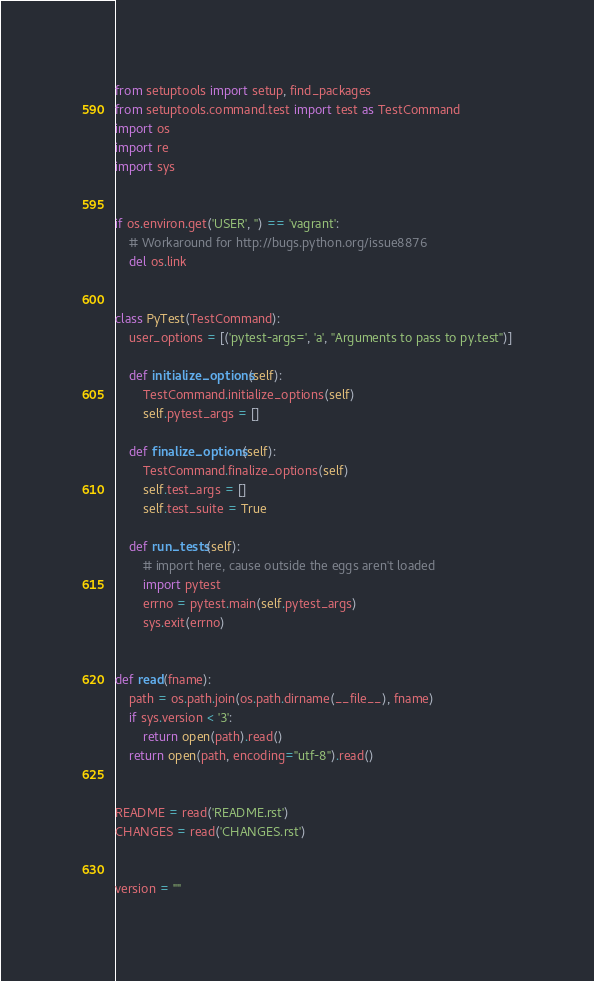<code> <loc_0><loc_0><loc_500><loc_500><_Python_>from setuptools import setup, find_packages
from setuptools.command.test import test as TestCommand
import os
import re
import sys


if os.environ.get('USER', '') == 'vagrant':
    # Workaround for http://bugs.python.org/issue8876
    del os.link


class PyTest(TestCommand):
    user_options = [('pytest-args=', 'a', "Arguments to pass to py.test")]

    def initialize_options(self):
        TestCommand.initialize_options(self)
        self.pytest_args = []

    def finalize_options(self):
        TestCommand.finalize_options(self)
        self.test_args = []
        self.test_suite = True

    def run_tests(self):
        # import here, cause outside the eggs aren't loaded
        import pytest
        errno = pytest.main(self.pytest_args)
        sys.exit(errno)


def read(fname):
    path = os.path.join(os.path.dirname(__file__), fname)
    if sys.version < '3':
        return open(path).read()
    return open(path, encoding="utf-8").read()


README = read('README.rst')
CHANGES = read('CHANGES.rst')


version = ""
</code> 